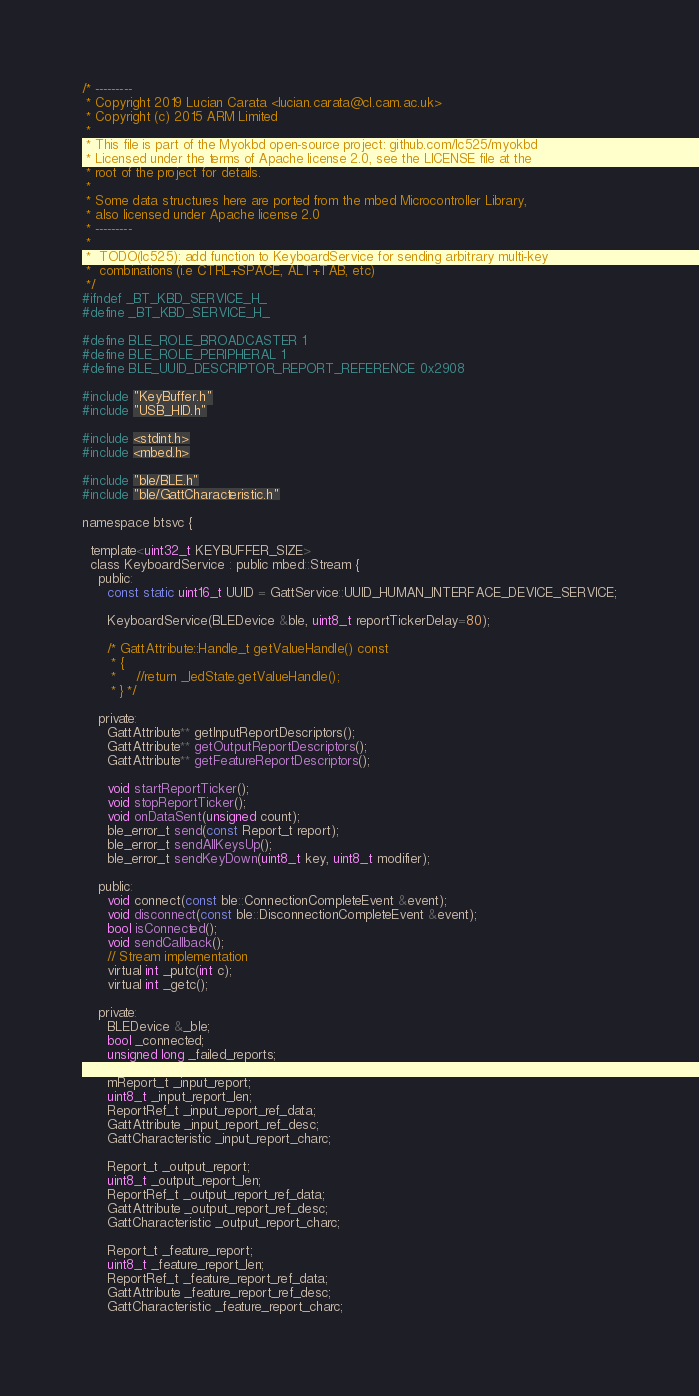<code> <loc_0><loc_0><loc_500><loc_500><_C_>/* ---------
 * Copyright 2019 Lucian Carata <lucian.carata@cl.cam.ac.uk>
 * Copyright (c) 2015 ARM Limited
 *
 * This file is part of the Myokbd open-source project: github.com/lc525/myokbd
 * Licensed under the terms of Apache license 2.0, see the LICENSE file at the
 * root of the project for details.
 *
 * Some data structures here are ported from the mbed Microcontroller Library,
 * also licensed under Apache license 2.0
 * ---------
 *
 *  TODO(lc525): add function to KeyboardService for sending arbitrary multi-key
 *  combinations (i.e CTRL+SPACE, ALT+TAB, etc)
 */
#ifndef _BT_KBD_SERVICE_H_
#define _BT_KBD_SERVICE_H_

#define BLE_ROLE_BROADCASTER 1
#define BLE_ROLE_PERIPHERAL 1
#define BLE_UUID_DESCRIPTOR_REPORT_REFERENCE 0x2908

#include "KeyBuffer.h"
#include "USB_HID.h"

#include <stdint.h>
#include <mbed.h>

#include "ble/BLE.h"
#include "ble/GattCharacteristic.h"

namespace btsvc {

  template<uint32_t KEYBUFFER_SIZE>
  class KeyboardService : public mbed::Stream {
    public:
      const static uint16_t UUID = GattService::UUID_HUMAN_INTERFACE_DEVICE_SERVICE;

      KeyboardService(BLEDevice &ble, uint8_t reportTickerDelay=80);

      /* GattAttribute::Handle_t getValueHandle() const
       * {
       *     //return _ledState.getValueHandle();
       * } */

    private:
      GattAttribute** getInputReportDescriptors();
      GattAttribute** getOutputReportDescriptors();
      GattAttribute** getFeatureReportDescriptors();

      void startReportTicker();
      void stopReportTicker();
      void onDataSent(unsigned count);
      ble_error_t send(const Report_t report);
      ble_error_t sendAllKeysUp();
      ble_error_t sendKeyDown(uint8_t key, uint8_t modifier);

    public:
      void connect(const ble::ConnectionCompleteEvent &event);
      void disconnect(const ble::DisconnectionCompleteEvent &event);
      bool isConnected();
      void sendCallback();
      // Stream implementation
      virtual int _putc(int c);
      virtual int _getc();

    private:
      BLEDevice &_ble;
      bool _connected;
      unsigned long _failed_reports;

      mReport_t _input_report;
      uint8_t _input_report_len;
      ReportRef_t _input_report_ref_data;
      GattAttribute _input_report_ref_desc;
      GattCharacteristic _input_report_charc;

      Report_t _output_report;
      uint8_t _output_report_len;
      ReportRef_t _output_report_ref_data;
      GattAttribute _output_report_ref_desc;
      GattCharacteristic _output_report_charc;

      Report_t _feature_report;
      uint8_t _feature_report_len;
      ReportRef_t _feature_report_ref_data;
      GattAttribute _feature_report_ref_desc;
      GattCharacteristic _feature_report_charc;
</code> 